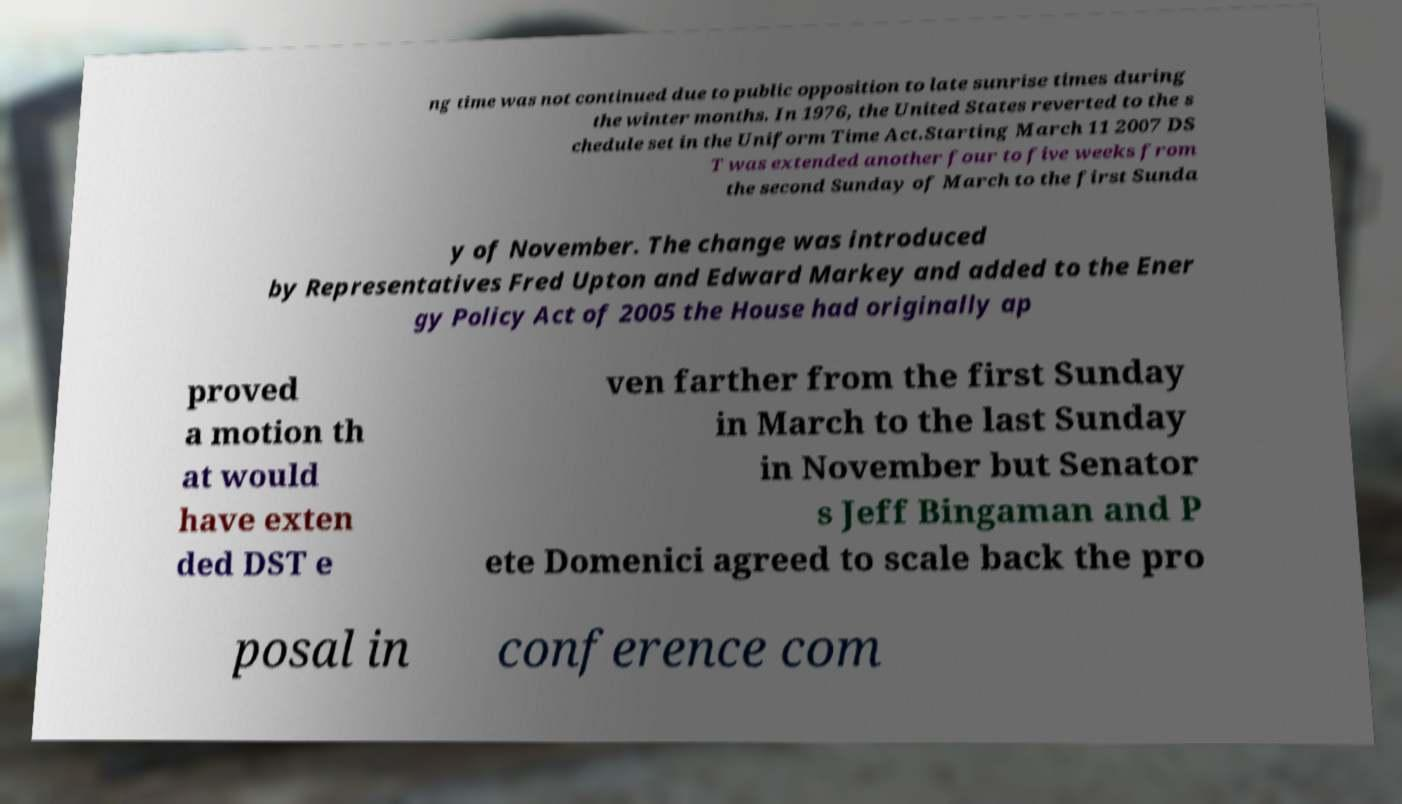Can you accurately transcribe the text from the provided image for me? ng time was not continued due to public opposition to late sunrise times during the winter months. In 1976, the United States reverted to the s chedule set in the Uniform Time Act.Starting March 11 2007 DS T was extended another four to five weeks from the second Sunday of March to the first Sunda y of November. The change was introduced by Representatives Fred Upton and Edward Markey and added to the Ener gy Policy Act of 2005 the House had originally ap proved a motion th at would have exten ded DST e ven farther from the first Sunday in March to the last Sunday in November but Senator s Jeff Bingaman and P ete Domenici agreed to scale back the pro posal in conference com 